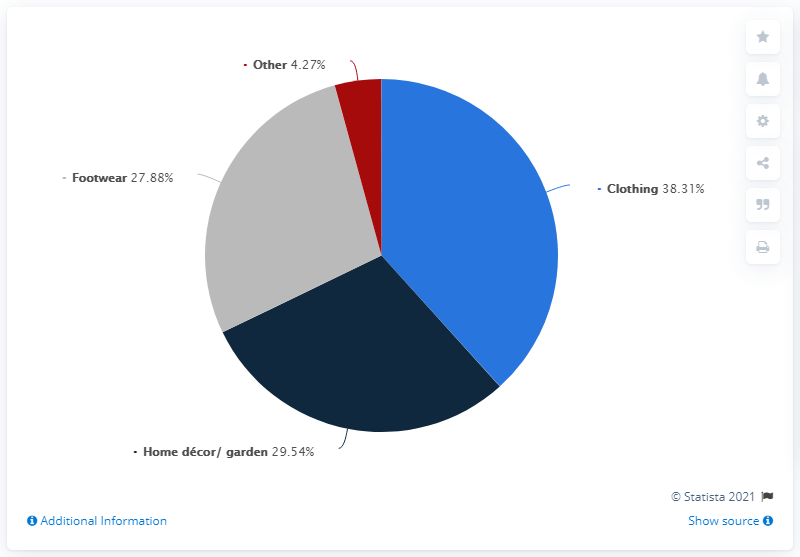Highlight a few significant elements in this photo. The total amount of clothing and home decor is 67.85. After the reopening of shopping centers, a significant percentage of Poles, approximately 38.31%, are expected to visit clothing stores. The color grey is typically represented in footwear. 